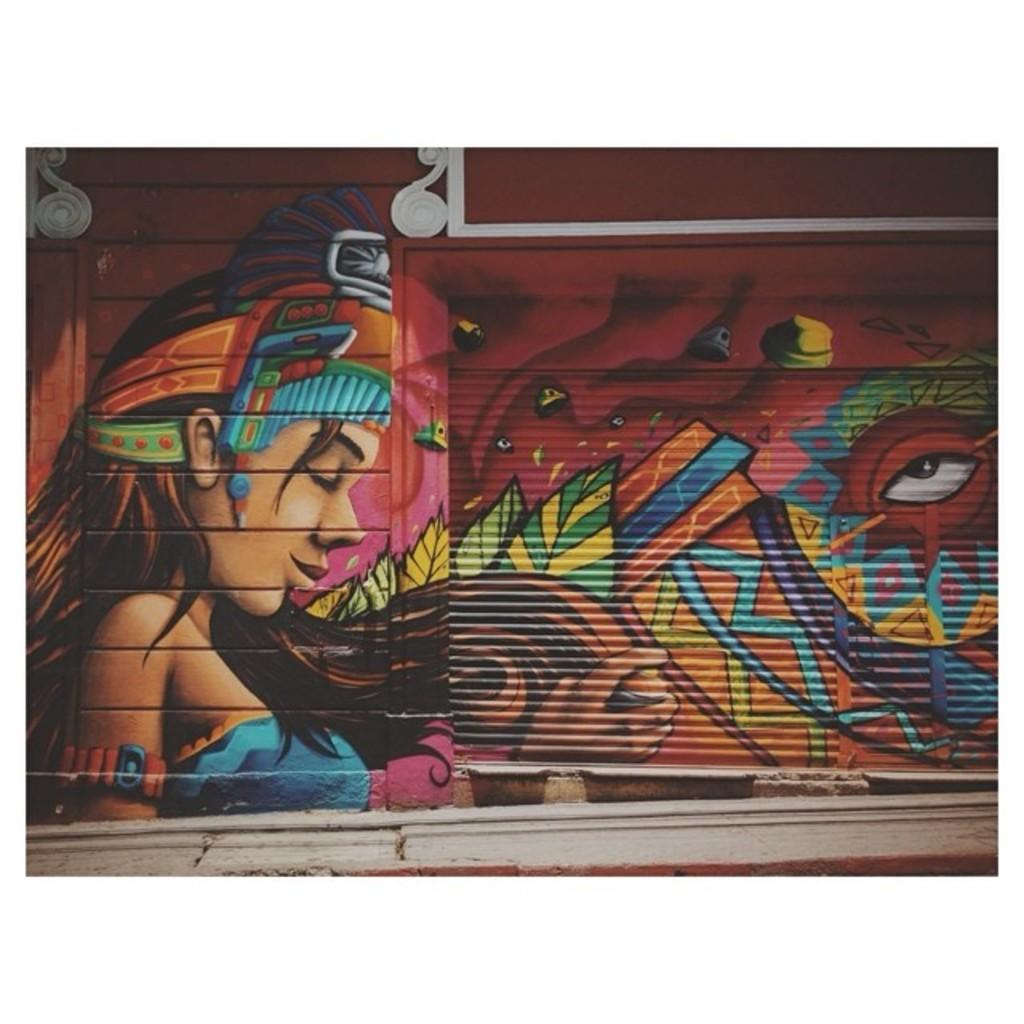What type of path is visible at the bottom of the image? There is a footpath at the bottom of the image. What can be seen on the wall in the background of the image? There is graffiti on a wall in the background of the image. What type of card is being used to coast down the footpath in the image? There is no card or coasting activity present in the image; it only features a footpath and graffiti on a wall. Is there a place to sleep near the footpath in the image? The image does not show any sleeping arrangements or facilities near the footpath. 